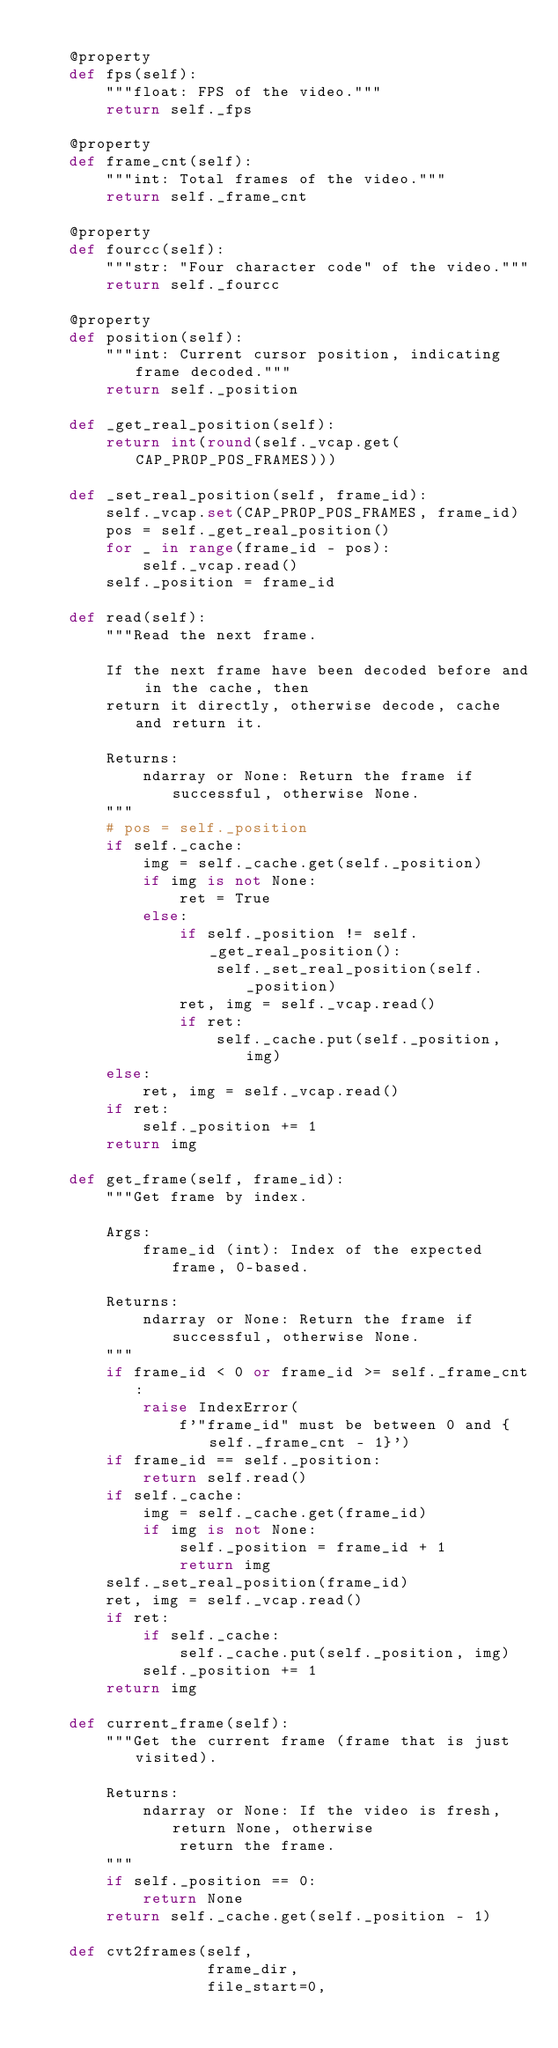<code> <loc_0><loc_0><loc_500><loc_500><_Python_>
    @property
    def fps(self):
        """float: FPS of the video."""
        return self._fps

    @property
    def frame_cnt(self):
        """int: Total frames of the video."""
        return self._frame_cnt

    @property
    def fourcc(self):
        """str: "Four character code" of the video."""
        return self._fourcc

    @property
    def position(self):
        """int: Current cursor position, indicating frame decoded."""
        return self._position

    def _get_real_position(self):
        return int(round(self._vcap.get(CAP_PROP_POS_FRAMES)))

    def _set_real_position(self, frame_id):
        self._vcap.set(CAP_PROP_POS_FRAMES, frame_id)
        pos = self._get_real_position()
        for _ in range(frame_id - pos):
            self._vcap.read()
        self._position = frame_id

    def read(self):
        """Read the next frame.

        If the next frame have been decoded before and in the cache, then
        return it directly, otherwise decode, cache and return it.

        Returns:
            ndarray or None: Return the frame if successful, otherwise None.
        """
        # pos = self._position
        if self._cache:
            img = self._cache.get(self._position)
            if img is not None:
                ret = True
            else:
                if self._position != self._get_real_position():
                    self._set_real_position(self._position)
                ret, img = self._vcap.read()
                if ret:
                    self._cache.put(self._position, img)
        else:
            ret, img = self._vcap.read()
        if ret:
            self._position += 1
        return img

    def get_frame(self, frame_id):
        """Get frame by index.

        Args:
            frame_id (int): Index of the expected frame, 0-based.

        Returns:
            ndarray or None: Return the frame if successful, otherwise None.
        """
        if frame_id < 0 or frame_id >= self._frame_cnt:
            raise IndexError(
                f'"frame_id" must be between 0 and {self._frame_cnt - 1}')
        if frame_id == self._position:
            return self.read()
        if self._cache:
            img = self._cache.get(frame_id)
            if img is not None:
                self._position = frame_id + 1
                return img
        self._set_real_position(frame_id)
        ret, img = self._vcap.read()
        if ret:
            if self._cache:
                self._cache.put(self._position, img)
            self._position += 1
        return img

    def current_frame(self):
        """Get the current frame (frame that is just visited).

        Returns:
            ndarray or None: If the video is fresh, return None, otherwise
                return the frame.
        """
        if self._position == 0:
            return None
        return self._cache.get(self._position - 1)

    def cvt2frames(self,
                   frame_dir,
                   file_start=0,</code> 